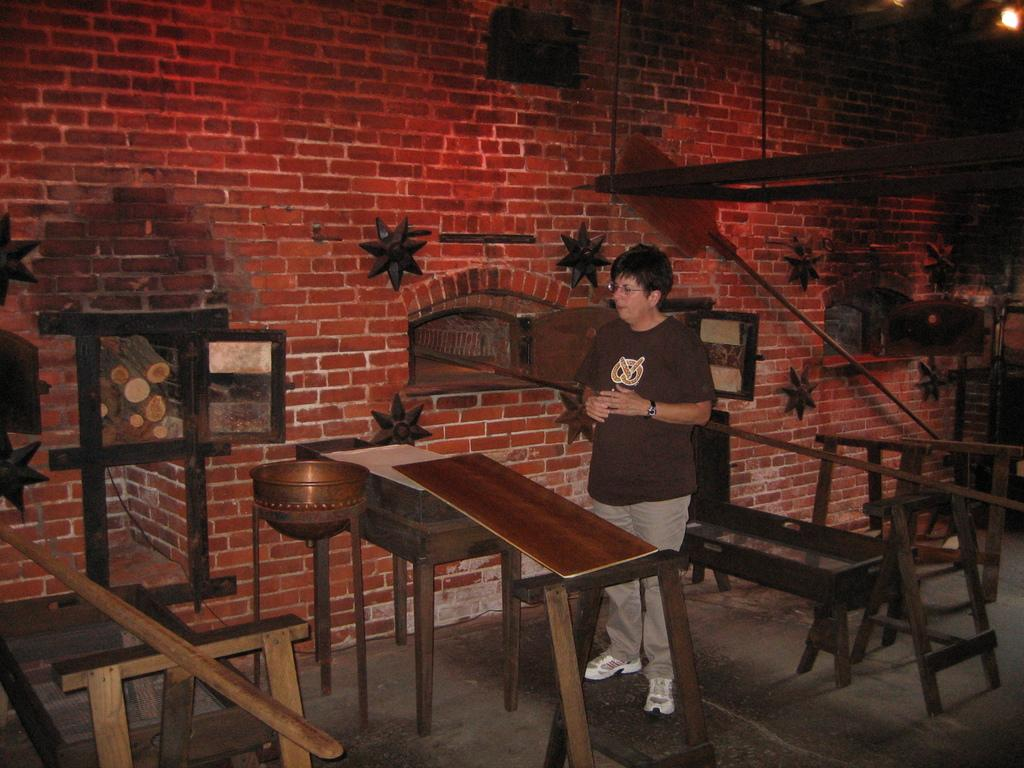What is the person in the image doing? The person is standing in front of a table. How many tables can be seen in the image? There are multiple tables visible in the image. What is the condition of the wall in the image? The wall with breaks is visible. What type of locket is the tiger wearing in the scene? There is no tiger or locket present in the image; it only features a person standing in front of a table and a wall with breaks. 